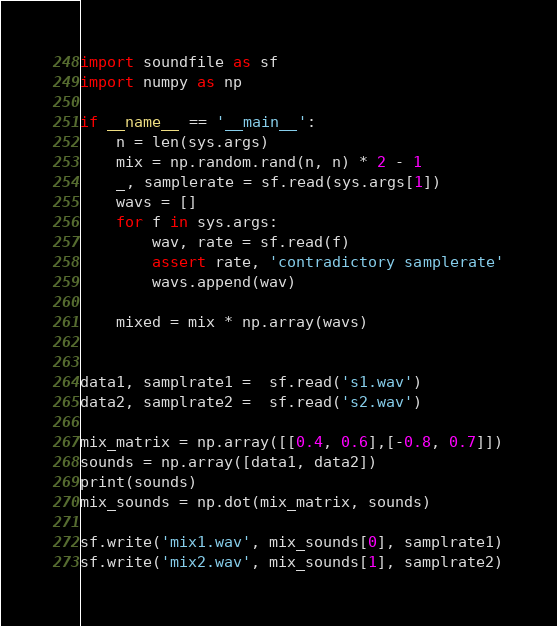Convert code to text. <code><loc_0><loc_0><loc_500><loc_500><_Python_>import soundfile as sf
import numpy as np

if __name__ == '__main__':
    n = len(sys.args)
    mix = np.random.rand(n, n) * 2 - 1
    _, samplerate = sf.read(sys.args[1])
    wavs = []
    for f in sys.args:
        wav, rate = sf.read(f)
        assert rate, 'contradictory samplerate'
        wavs.append(wav)

    mixed = mix * np.array(wavs)


data1, samplrate1 =  sf.read('s1.wav')
data2, samplrate2 =  sf.read('s2.wav')

mix_matrix = np.array([[0.4, 0.6],[-0.8, 0.7]])
sounds = np.array([data1, data2])
print(sounds)
mix_sounds = np.dot(mix_matrix, sounds)

sf.write('mix1.wav', mix_sounds[0], samplrate1)
sf.write('mix2.wav', mix_sounds[1], samplrate2)
</code> 